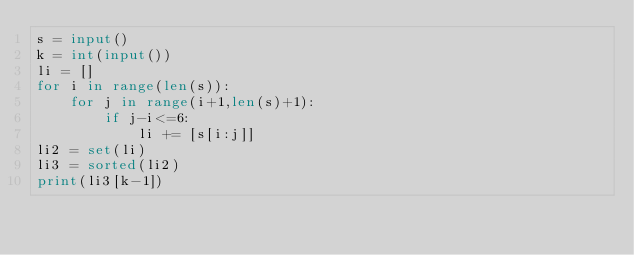Convert code to text. <code><loc_0><loc_0><loc_500><loc_500><_Python_>s = input()
k = int(input())
li = []
for i in range(len(s)):
    for j in range(i+1,len(s)+1):
        if j-i<=6:
            li += [s[i:j]]
li2 = set(li)
li3 = sorted(li2)
print(li3[k-1])</code> 